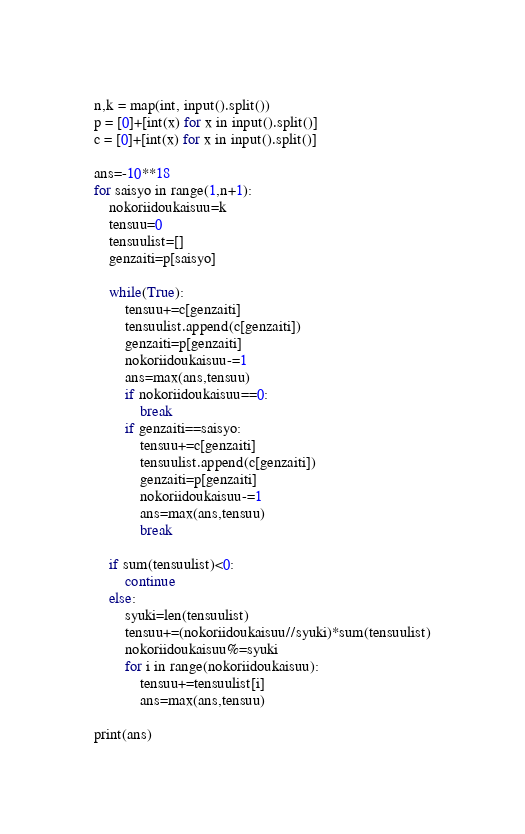Convert code to text. <code><loc_0><loc_0><loc_500><loc_500><_Python_>n,k = map(int, input().split())
p = [0]+[int(x) for x in input().split()]
c = [0]+[int(x) for x in input().split()]

ans=-10**18
for saisyo in range(1,n+1):
    nokoriidoukaisuu=k
    tensuu=0
    tensuulist=[]
    genzaiti=p[saisyo]
    
    while(True):
        tensuu+=c[genzaiti]
        tensuulist.append(c[genzaiti])
        genzaiti=p[genzaiti]
        nokoriidoukaisuu-=1
        ans=max(ans,tensuu)
        if nokoriidoukaisuu==0:
            break
        if genzaiti==saisyo:
            tensuu+=c[genzaiti]
            tensuulist.append(c[genzaiti])
            genzaiti=p[genzaiti]
            nokoriidoukaisuu-=1
            ans=max(ans,tensuu)
            break

    if sum(tensuulist)<0:
        continue
    else:
        syuki=len(tensuulist)
        tensuu+=(nokoriidoukaisuu//syuki)*sum(tensuulist)
        nokoriidoukaisuu%=syuki
        for i in range(nokoriidoukaisuu):
            tensuu+=tensuulist[i]
            ans=max(ans,tensuu)

print(ans)
</code> 